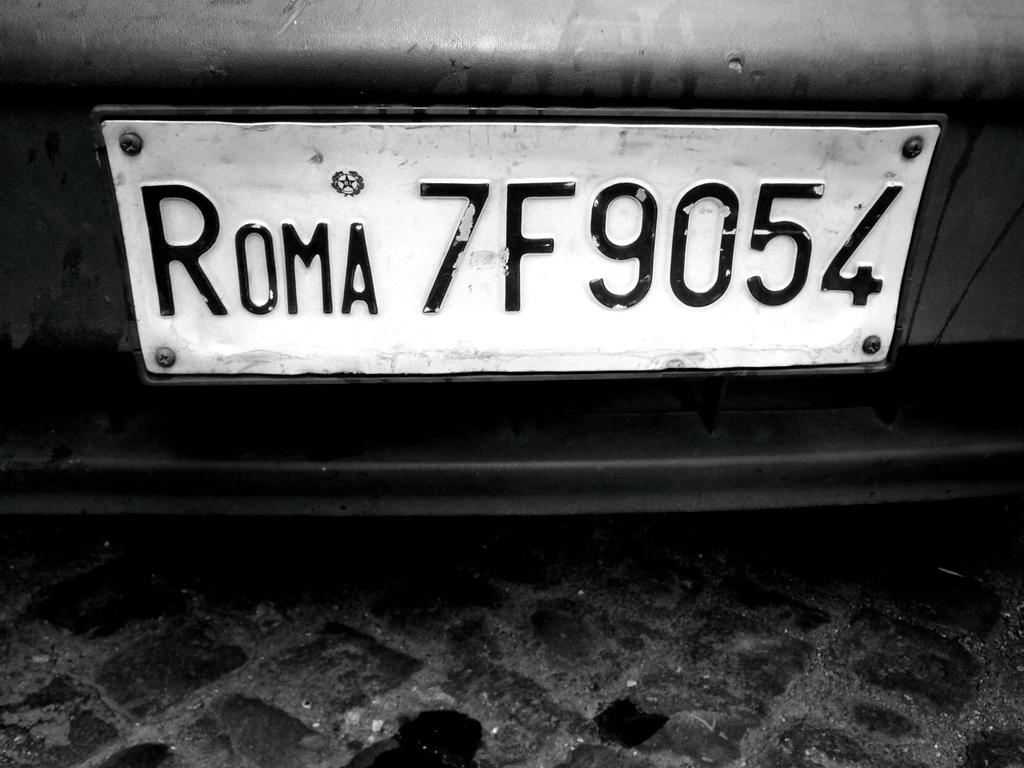<image>
Describe the image concisely. Licence plate for a car which has the numbers 7F9054 